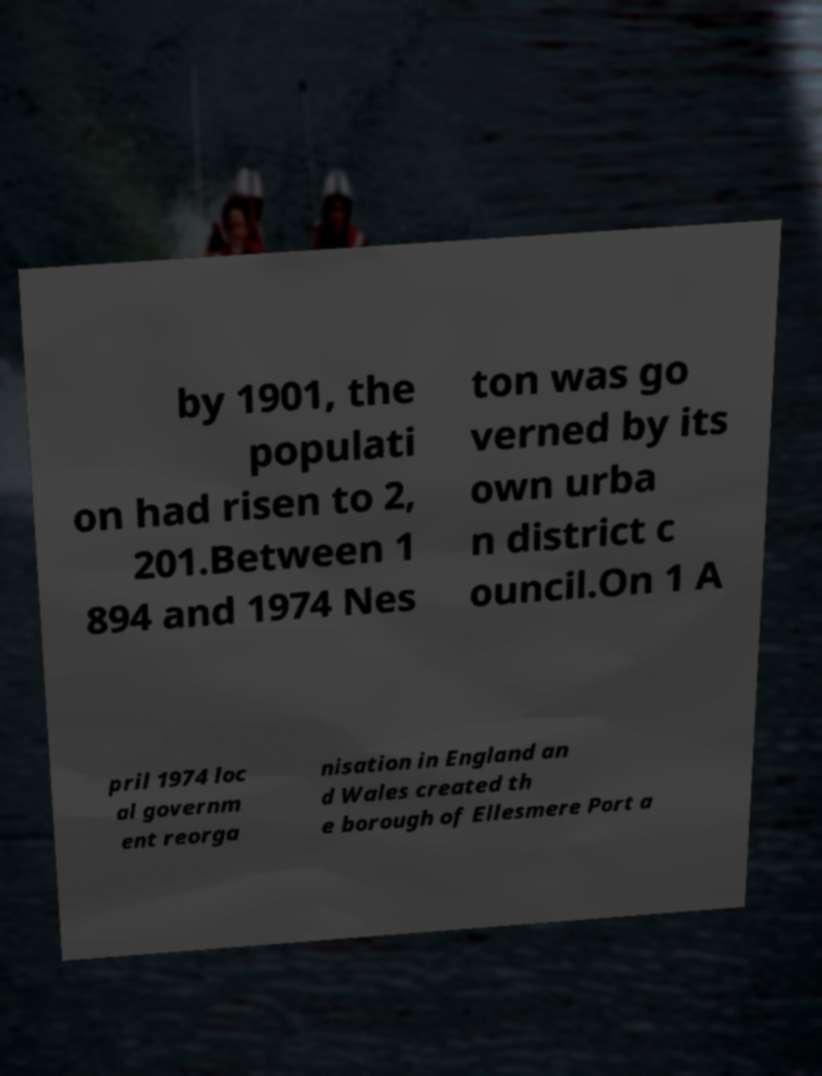Please identify and transcribe the text found in this image. by 1901, the populati on had risen to 2, 201.Between 1 894 and 1974 Nes ton was go verned by its own urba n district c ouncil.On 1 A pril 1974 loc al governm ent reorga nisation in England an d Wales created th e borough of Ellesmere Port a 